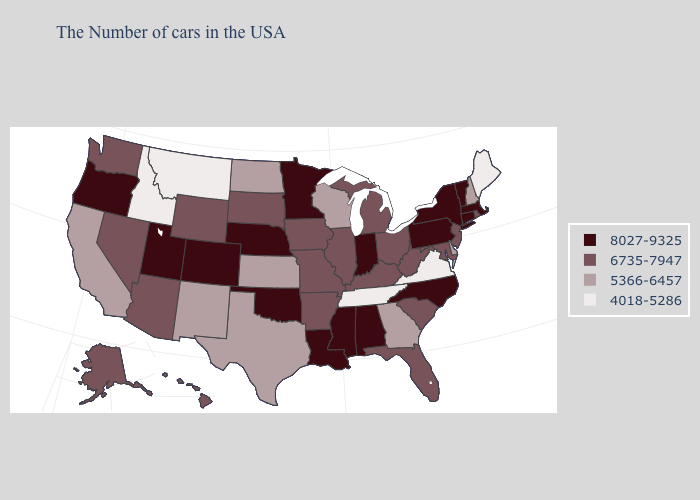Is the legend a continuous bar?
Write a very short answer. No. Which states hav the highest value in the South?
Answer briefly. North Carolina, Alabama, Mississippi, Louisiana, Oklahoma. What is the lowest value in the USA?
Quick response, please. 4018-5286. Among the states that border Kansas , does Nebraska have the lowest value?
Be succinct. No. Does the map have missing data?
Keep it brief. No. What is the highest value in the USA?
Answer briefly. 8027-9325. What is the lowest value in states that border Iowa?
Keep it brief. 5366-6457. What is the highest value in states that border New Hampshire?
Quick response, please. 8027-9325. Name the states that have a value in the range 5366-6457?
Concise answer only. New Hampshire, Delaware, Georgia, Wisconsin, Kansas, Texas, North Dakota, New Mexico, California. Name the states that have a value in the range 5366-6457?
Write a very short answer. New Hampshire, Delaware, Georgia, Wisconsin, Kansas, Texas, North Dakota, New Mexico, California. How many symbols are there in the legend?
Write a very short answer. 4. Name the states that have a value in the range 4018-5286?
Give a very brief answer. Maine, Virginia, Tennessee, Montana, Idaho. What is the value of Texas?
Concise answer only. 5366-6457. What is the lowest value in states that border Alabama?
Quick response, please. 4018-5286. What is the value of Texas?
Write a very short answer. 5366-6457. 